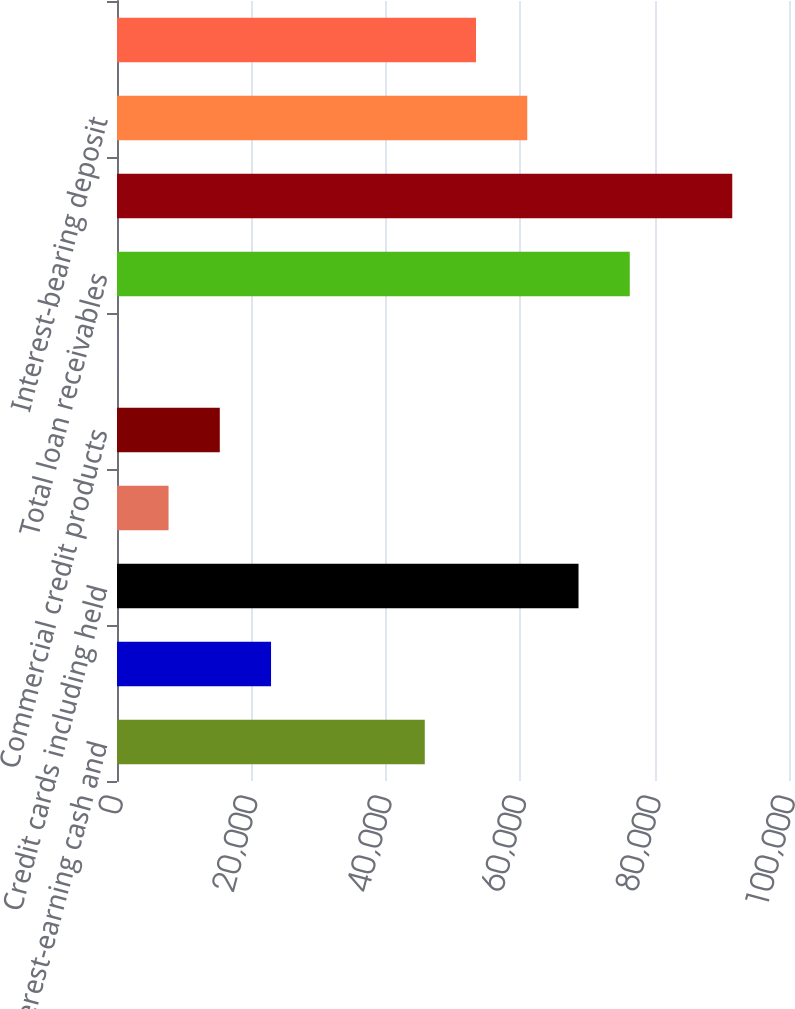<chart> <loc_0><loc_0><loc_500><loc_500><bar_chart><fcel>Interest-earning cash and<fcel>Securities available for sale<fcel>Credit cards including held<fcel>Consumer installment loans<fcel>Commercial credit products<fcel>Other<fcel>Total loan receivables<fcel>Total interest-earning assets<fcel>Interest-bearing deposit<fcel>Borrowings of consolidated<nl><fcel>45800.4<fcel>22922.7<fcel>68678.1<fcel>7670.9<fcel>15296.8<fcel>45<fcel>76304<fcel>91555.8<fcel>61052.2<fcel>53426.3<nl></chart> 